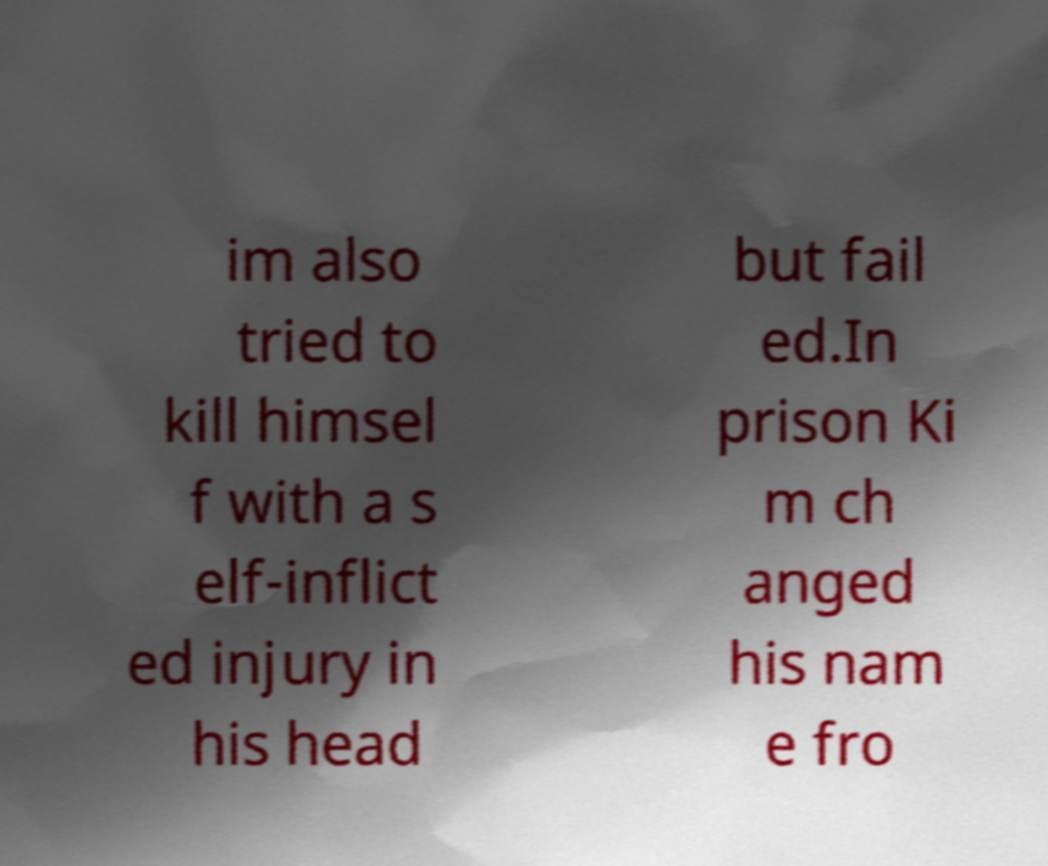For documentation purposes, I need the text within this image transcribed. Could you provide that? im also tried to kill himsel f with a s elf-inflict ed injury in his head but fail ed.In prison Ki m ch anged his nam e fro 